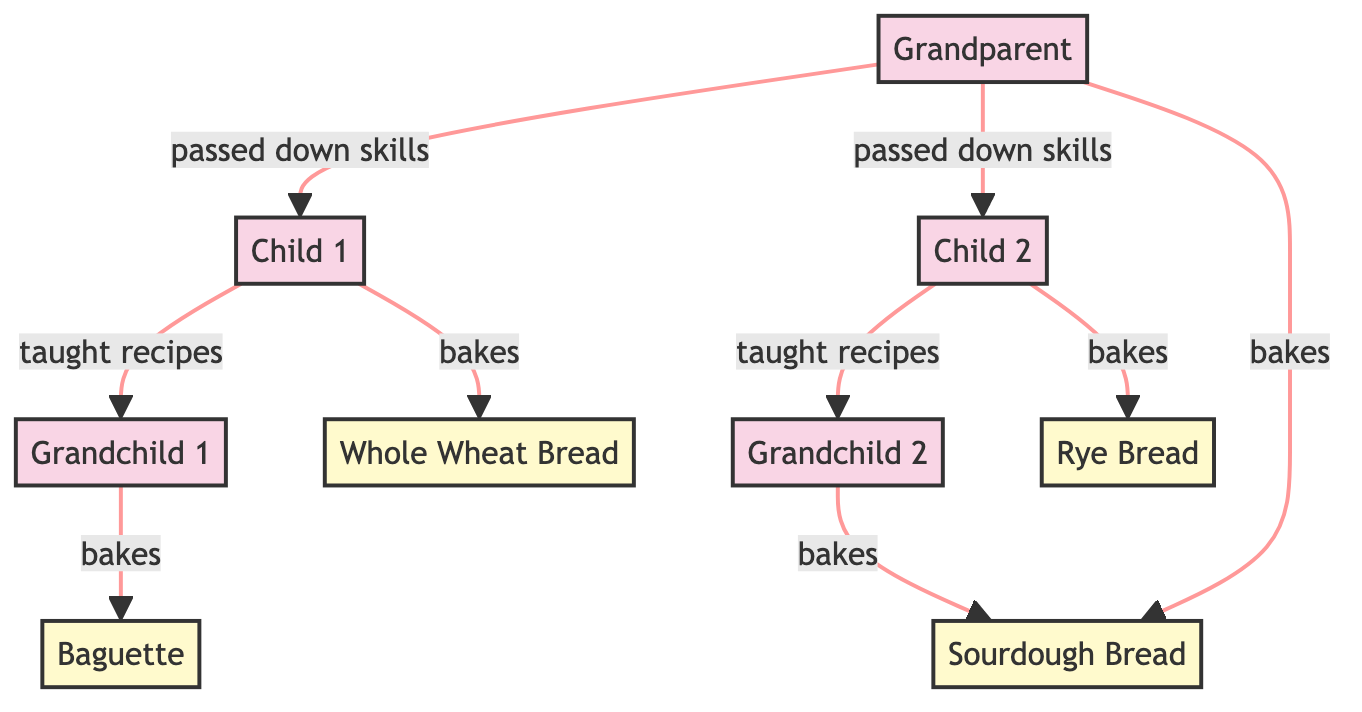What is the total number of family members shown in the diagram? The diagram includes five family members: the grandparent, two children, and two grandchildren. This can be counted directly from the nodes labeled as family members.
Answer: 5 Which bread is baked by Child 2? The diagram shows an edge from Child 2 to the "Rye Bread," indicating that Child 2 bakes this type of bread.
Answer: Rye Bread Who taught the recipes to Grandchild 2? According to the diagram, there is an edge from Child 2 to Grandchild 2 labeled "taught recipes," meaning Child 2 was the one who taught them.
Answer: Child 2 How many types of bread are mentioned in the diagram? The diagram lists four types of bread: Sourdough Bread, Whole Wheat Bread, Rye Bread, and Baguette. These can be counted directly in the nodes labeled as bread.
Answer: 4 What skills did the Grandparent pass down? The diagram shows that the Grandparent passed down skills to both Child 1 and Child 2, as indicated by the edges labeled "passed down skills."
Answer: passed down skills Which grandchild bakes the Baguette? The diagram indicates that Grandchild 1 is linked to the Baguette by an edge labeled "bakes," specifying that this grandchild is the one baking it.
Answer: Grandchild 1 What is the relationship between Grandparent and Child 1? There is a directed edge from Grandparent to Child 1 labeled "passed down skills," which means the relationship involves the Grandparent teaching or imparting skills to Child 1.
Answer: passed down skills Which bread is baked by both Grandchild 2 and the Grandparent? The diagram shows that both the Grandparent and Grandchild 2 have edges that link them to Sourdough Bread, meaning both are involved in baking this type.
Answer: Sourdough Bread What is the relationship between Child 1 and Grandchild 1? There is an edge from Child 1 to Grandchild 1 labeled "taught recipes," indicating that Child 1 passed on particular recipes to Grandchild 1.
Answer: taught recipes 